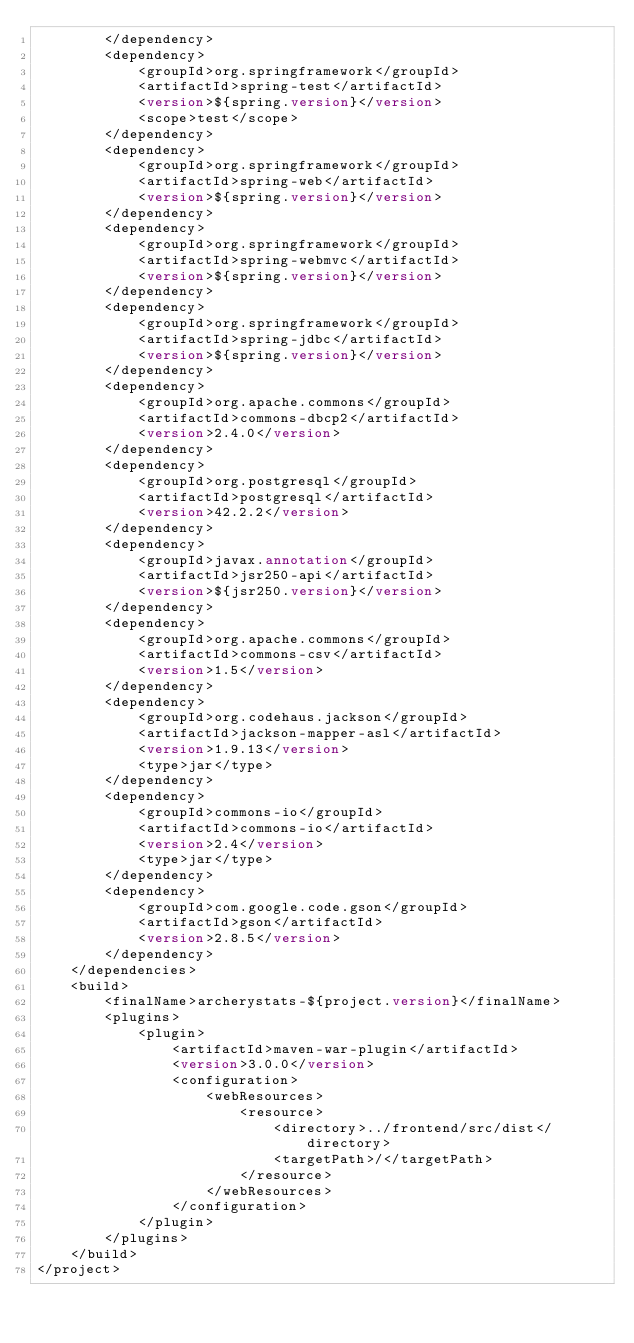Convert code to text. <code><loc_0><loc_0><loc_500><loc_500><_XML_>        </dependency>
        <dependency>
            <groupId>org.springframework</groupId>
            <artifactId>spring-test</artifactId>
            <version>${spring.version}</version>
            <scope>test</scope>
        </dependency>
        <dependency>
            <groupId>org.springframework</groupId>
            <artifactId>spring-web</artifactId>
            <version>${spring.version}</version>
        </dependency>
        <dependency>
            <groupId>org.springframework</groupId>
            <artifactId>spring-webmvc</artifactId>
            <version>${spring.version}</version>
        </dependency>    
        <dependency>
            <groupId>org.springframework</groupId>
            <artifactId>spring-jdbc</artifactId>
            <version>${spring.version}</version>
        </dependency>   
        <dependency>
            <groupId>org.apache.commons</groupId>
            <artifactId>commons-dbcp2</artifactId>
            <version>2.4.0</version>
        </dependency>                
        <dependency>
            <groupId>org.postgresql</groupId>
            <artifactId>postgresql</artifactId>
            <version>42.2.2</version>
        </dependency>                
        <dependency>
            <groupId>javax.annotation</groupId>
            <artifactId>jsr250-api</artifactId>
            <version>${jsr250.version}</version>
        </dependency>
        <dependency>
            <groupId>org.apache.commons</groupId>
            <artifactId>commons-csv</artifactId>
            <version>1.5</version>
        </dependency>
        <dependency>
            <groupId>org.codehaus.jackson</groupId>
            <artifactId>jackson-mapper-asl</artifactId>
            <version>1.9.13</version>
            <type>jar</type>
        </dependency>
        <dependency>
            <groupId>commons-io</groupId>
            <artifactId>commons-io</artifactId>
            <version>2.4</version>
            <type>jar</type>
        </dependency>      
        <dependency>
            <groupId>com.google.code.gson</groupId>
            <artifactId>gson</artifactId>
            <version>2.8.5</version>
        </dependency>            
    </dependencies>            
    <build>
        <finalName>archerystats-${project.version}</finalName>
        <plugins>            
            <plugin>
                <artifactId>maven-war-plugin</artifactId>
                <version>3.0.0</version>
                <configuration>
                    <webResources>
                        <resource>
                            <directory>../frontend/src/dist</directory>
                            <targetPath>/</targetPath>                       
                        </resource>
                    </webResources>
                </configuration>
            </plugin>                       
        </plugins>  
    </build>
</project>
</code> 